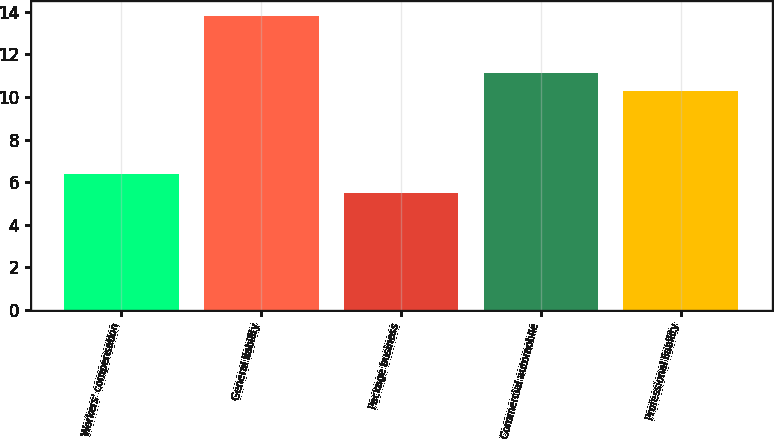Convert chart. <chart><loc_0><loc_0><loc_500><loc_500><bar_chart><fcel>Workers' compensation<fcel>General liability<fcel>Package business<fcel>Commercial automobile<fcel>Professional liability<nl><fcel>6.4<fcel>13.8<fcel>5.5<fcel>11.13<fcel>10.3<nl></chart> 